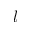<formula> <loc_0><loc_0><loc_500><loc_500>l</formula> 